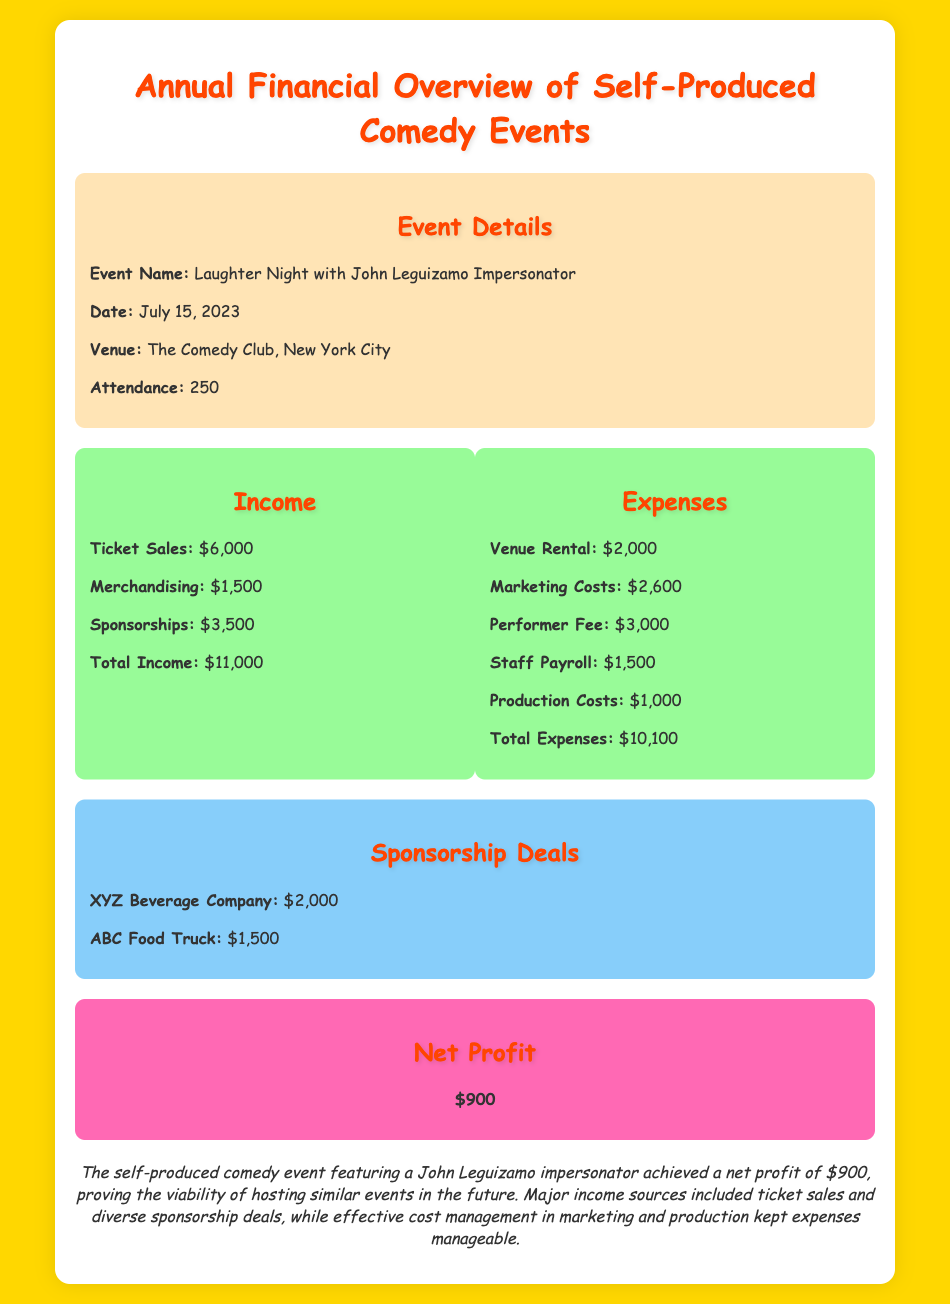What is the event name? The event name is presented in the document under event details, specifically labeled.
Answer: Laughter Night with John Leguizamo Impersonator What was the date of the event? The date of the event is provided in the event details section.
Answer: July 15, 2023 What was the total income from the event? The total income is the sum of all income sources listed in the financial summary.
Answer: $11,000 What were the marketing costs? The marketing costs are listed as part of the expenses in the financial summary.
Answer: $2,600 What was the performer fee? The performer fee is itemized in the expenses section of the financial summary.
Answer: $3,000 How much did the XYZ Beverage Company sponsor? The sponsorship amount from XYZ Beverage Company is specifically mentioned in the sponsorship deals.
Answer: $2,000 What is the total profit from this event? The total profit, identified as net profit, is found in the net profit section of the document.
Answer: $900 Which venue hosted the event? The venue name can be found in the event details section of the document.
Answer: The Comedy Club, New York City How many people attended the event? Attendance figures are provided as part of the event details.
Answer: 250 